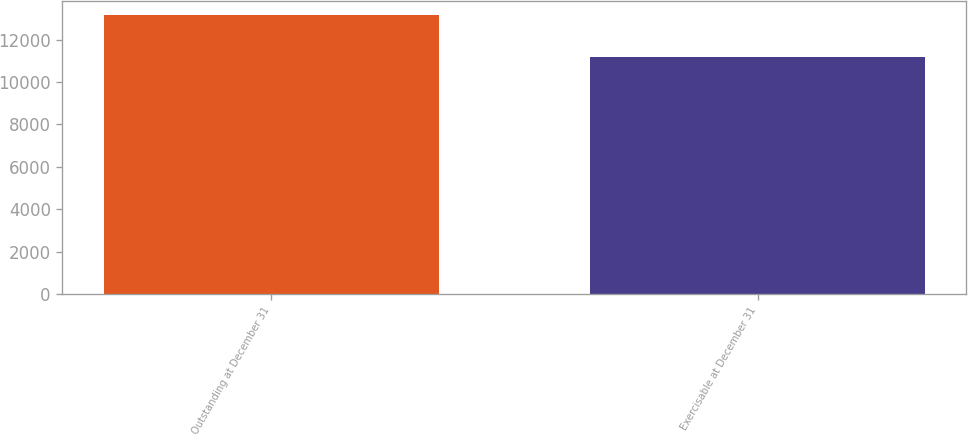<chart> <loc_0><loc_0><loc_500><loc_500><bar_chart><fcel>Outstanding at December 31<fcel>Exercisable at December 31<nl><fcel>13167<fcel>11172<nl></chart> 